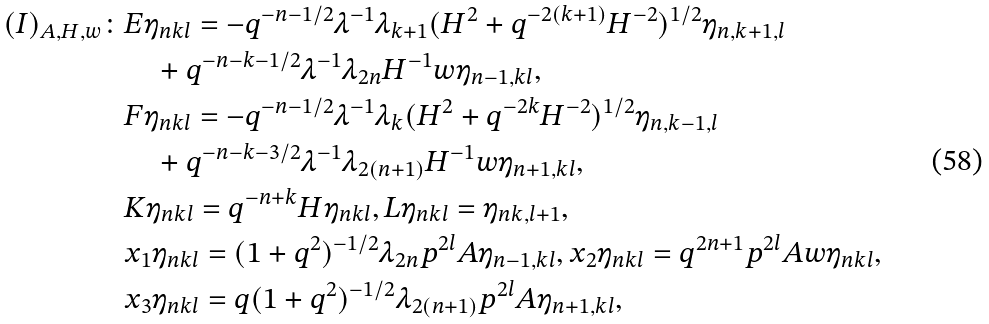<formula> <loc_0><loc_0><loc_500><loc_500>( I ) _ { A , H , w } \colon & E \eta _ { n k l } = - q ^ { - n - 1 / 2 } \lambda ^ { - 1 } \lambda _ { k + 1 } ( H ^ { 2 } + q ^ { - 2 ( k + 1 ) } H ^ { - 2 } ) ^ { 1 / 2 } \eta _ { n , k + 1 , l } \\ & \quad + q ^ { - n - k - 1 / 2 } \lambda ^ { - 1 } \lambda _ { 2 n } H ^ { - 1 } w \eta _ { n - 1 , k l } , \\ & F \eta _ { n k l } = - q ^ { - n - 1 / 2 } \lambda ^ { - 1 } \lambda _ { k } ( H ^ { 2 } + q ^ { - 2 k } H ^ { - 2 } ) ^ { 1 / 2 } \eta _ { n , k - 1 , l } \\ & \quad + q ^ { - n - k - 3 / 2 } \lambda ^ { - 1 } \lambda _ { 2 ( n + 1 ) } H ^ { - 1 } w \eta _ { n + 1 , k l } , \\ & K \eta _ { n k l } = q ^ { - n + k } H \eta _ { n k l } , L \eta _ { n k l } = \eta _ { n k , l + 1 } , \\ & x _ { 1 } \eta _ { n k l } = ( 1 + q ^ { 2 } ) ^ { - 1 / 2 } \lambda _ { 2 n } p ^ { 2 l } A \eta _ { n - 1 , k l } , x _ { 2 } \eta _ { n k l } = q ^ { 2 n + 1 } p ^ { 2 l } A w \eta _ { n k l } , \\ & x _ { 3 } \eta _ { n k l } = q ( 1 + q ^ { 2 } ) ^ { - 1 / 2 } \lambda _ { 2 ( n + 1 ) } p ^ { 2 l } A \eta _ { n + 1 , k l } ,</formula> 